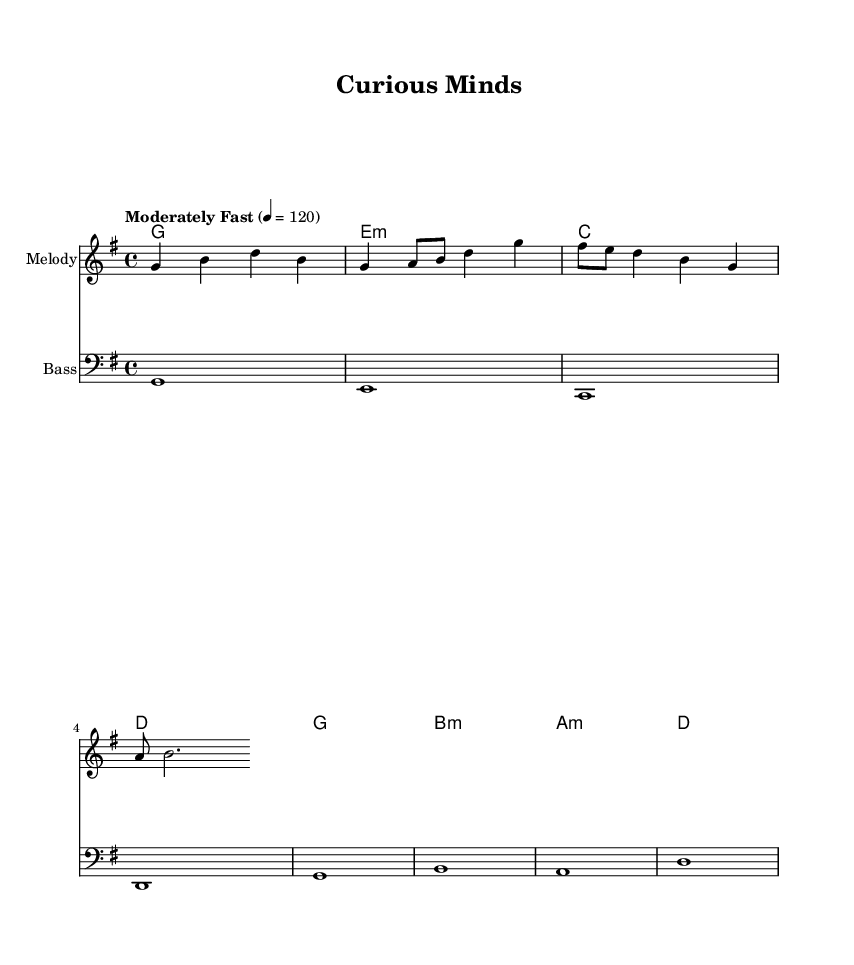What is the key signature of this music? The key signature indicated in the sheet music is G major, which has one sharp (F#). This is identifiable by looking at the key signature symbol at the beginning of the staff lines.
Answer: G major What is the time signature? The time signature is 4/4, which means there are four beats in each measure and the quarter note gets one beat. This is shown at the beginning of the staff.
Answer: 4/4 What is the tempo marking for this piece? The tempo marking in the music indicates "Moderately Fast" with a metronome marking of 120 beats per minute. This specifies the speed at which the piece should be played, located at the beginning of the score.
Answer: Moderately Fast, 120 Which chord is played during the first measure? The chord played in the first measure is G major, as indicated in the chord line where the first chord symbol shows 'g1'.
Answer: G major How many measures are there in the melody section? The melody section contains four measures. This can be counted by looking at the bars separating the notes in the melody line. Each bar indicates one measure.
Answer: Four measures What type of musical piece is this? This piece is categorized as Rhythm and Blues, reflecting its upbeat nature and thematic content that relates to curiosity and lifelong learning through the structure and harmonic progression typical of the genre.
Answer: Rhythm and Blues 